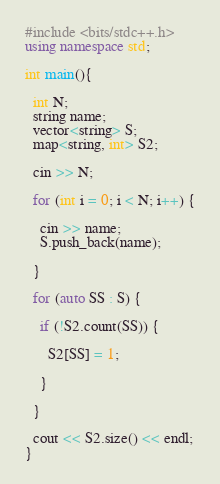Convert code to text. <code><loc_0><loc_0><loc_500><loc_500><_C++_>#include <bits/stdc++.h>
using namespace std;

int main(){
  
  int N;
  string name;
  vector<string> S;
  map<string, int> S2;
  
  cin >> N;
  
  for (int i = 0; i < N; i++) {
    
    cin >> name;
    S.push_back(name);
    
  }  
  
  for (auto SS : S) {
    
    if (!S2.count(SS)) {
      
      S2[SS] = 1;
      
    }  
    
  }  
  
  cout << S2.size() << endl;
}</code> 